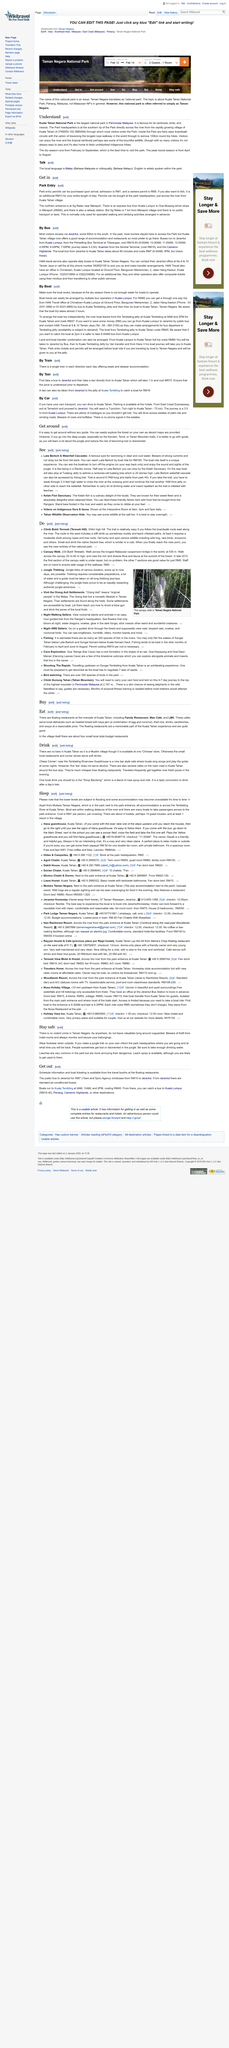Give some essential details in this illustration. Buses and boats are the type of public transport mentioned in the given information. The article suggests that you should visit Lata Berkoh and Waterfall Cascades, two breathtaking attractions that are worth a visit. The local language within the park is Malay. Boats run to Kuala Tembling up until 2 pm, which is the latest time. The hiking trail from park headquarters to the Lata Berkoh waterfall cascade is approximately 8/7 kilometers in length. 